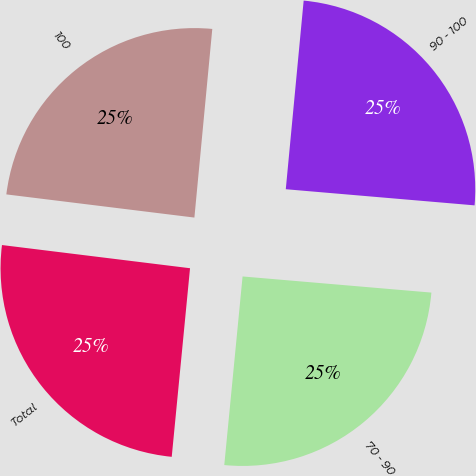Convert chart. <chart><loc_0><loc_0><loc_500><loc_500><pie_chart><fcel>70 - 90<fcel>90 - 100<fcel>100<fcel>Total<nl><fcel>25.18%<fcel>24.85%<fcel>24.55%<fcel>25.41%<nl></chart> 